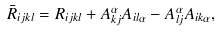<formula> <loc_0><loc_0><loc_500><loc_500>\bar { R } _ { i j k l } = R _ { i j k l } + A _ { k j } ^ { \alpha } A _ { i l \alpha } - A _ { l j } ^ { \alpha } A _ { i k \alpha } ,</formula> 